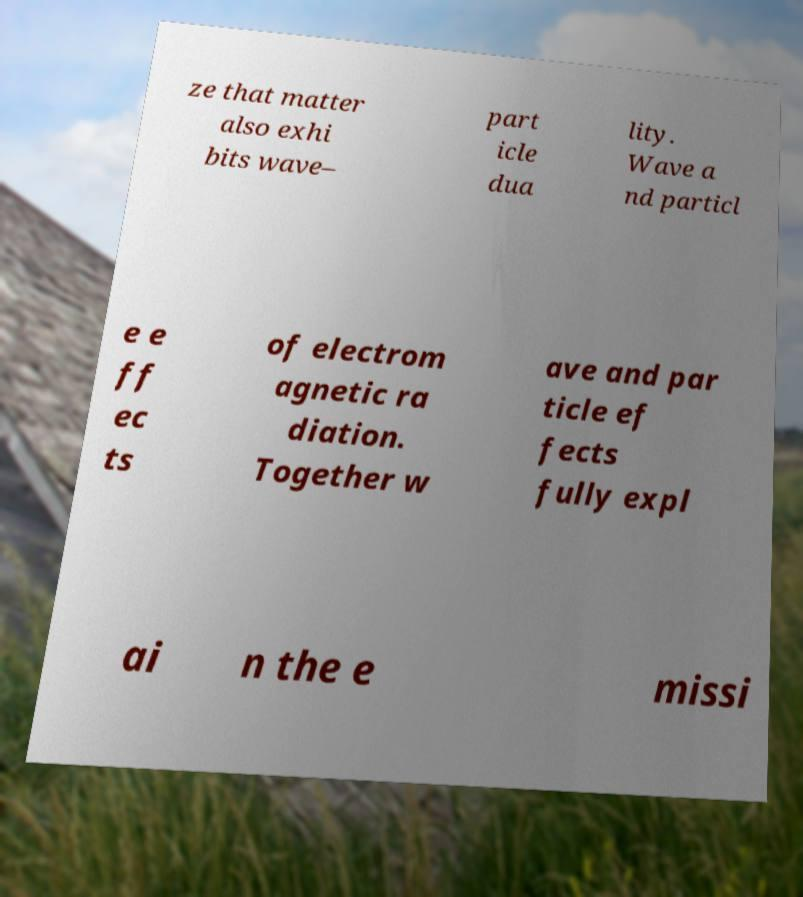What messages or text are displayed in this image? I need them in a readable, typed format. ze that matter also exhi bits wave– part icle dua lity. Wave a nd particl e e ff ec ts of electrom agnetic ra diation. Together w ave and par ticle ef fects fully expl ai n the e missi 